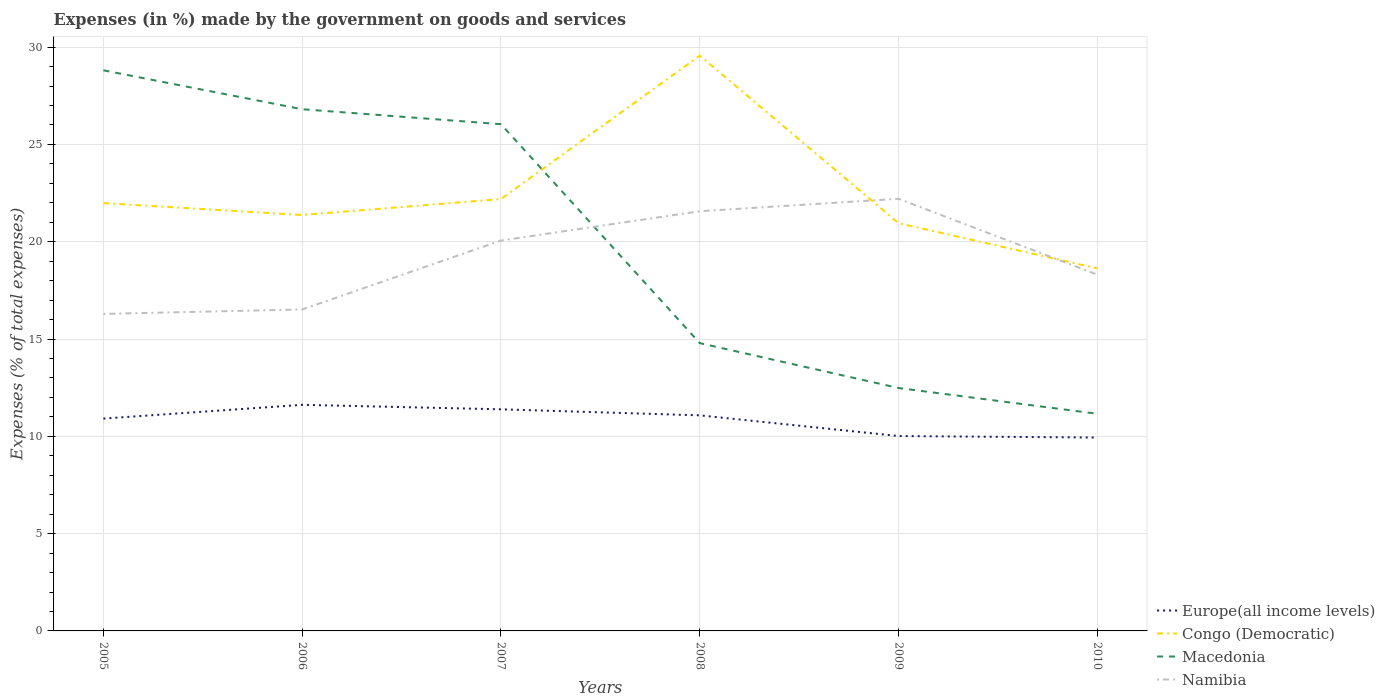Does the line corresponding to Namibia intersect with the line corresponding to Macedonia?
Keep it short and to the point. Yes. Is the number of lines equal to the number of legend labels?
Provide a short and direct response. Yes. Across all years, what is the maximum percentage of expenses made by the government on goods and services in Macedonia?
Keep it short and to the point. 11.16. In which year was the percentage of expenses made by the government on goods and services in Namibia maximum?
Offer a terse response. 2005. What is the total percentage of expenses made by the government on goods and services in Namibia in the graph?
Give a very brief answer. -5.92. What is the difference between the highest and the second highest percentage of expenses made by the government on goods and services in Congo (Democratic)?
Provide a short and direct response. 10.93. What is the difference between the highest and the lowest percentage of expenses made by the government on goods and services in Namibia?
Provide a succinct answer. 3. How many lines are there?
Offer a very short reply. 4. What is the difference between two consecutive major ticks on the Y-axis?
Give a very brief answer. 5. Are the values on the major ticks of Y-axis written in scientific E-notation?
Your response must be concise. No. Does the graph contain any zero values?
Provide a short and direct response. No. What is the title of the graph?
Offer a terse response. Expenses (in %) made by the government on goods and services. What is the label or title of the Y-axis?
Provide a succinct answer. Expenses (% of total expenses). What is the Expenses (% of total expenses) of Europe(all income levels) in 2005?
Give a very brief answer. 10.91. What is the Expenses (% of total expenses) of Congo (Democratic) in 2005?
Provide a succinct answer. 21.99. What is the Expenses (% of total expenses) of Macedonia in 2005?
Give a very brief answer. 28.81. What is the Expenses (% of total expenses) of Namibia in 2005?
Give a very brief answer. 16.29. What is the Expenses (% of total expenses) in Europe(all income levels) in 2006?
Ensure brevity in your answer.  11.62. What is the Expenses (% of total expenses) in Congo (Democratic) in 2006?
Provide a short and direct response. 21.37. What is the Expenses (% of total expenses) in Macedonia in 2006?
Your answer should be very brief. 26.81. What is the Expenses (% of total expenses) of Namibia in 2006?
Offer a terse response. 16.52. What is the Expenses (% of total expenses) of Europe(all income levels) in 2007?
Your response must be concise. 11.39. What is the Expenses (% of total expenses) of Congo (Democratic) in 2007?
Offer a terse response. 22.19. What is the Expenses (% of total expenses) of Macedonia in 2007?
Ensure brevity in your answer.  26.04. What is the Expenses (% of total expenses) in Namibia in 2007?
Ensure brevity in your answer.  20.06. What is the Expenses (% of total expenses) of Europe(all income levels) in 2008?
Provide a short and direct response. 11.08. What is the Expenses (% of total expenses) in Congo (Democratic) in 2008?
Provide a succinct answer. 29.56. What is the Expenses (% of total expenses) in Macedonia in 2008?
Provide a short and direct response. 14.79. What is the Expenses (% of total expenses) in Namibia in 2008?
Offer a terse response. 21.57. What is the Expenses (% of total expenses) in Europe(all income levels) in 2009?
Keep it short and to the point. 10.01. What is the Expenses (% of total expenses) in Congo (Democratic) in 2009?
Offer a very short reply. 20.95. What is the Expenses (% of total expenses) of Macedonia in 2009?
Ensure brevity in your answer.  12.48. What is the Expenses (% of total expenses) of Namibia in 2009?
Your answer should be compact. 22.21. What is the Expenses (% of total expenses) of Europe(all income levels) in 2010?
Provide a short and direct response. 9.94. What is the Expenses (% of total expenses) in Congo (Democratic) in 2010?
Your response must be concise. 18.63. What is the Expenses (% of total expenses) in Macedonia in 2010?
Keep it short and to the point. 11.16. What is the Expenses (% of total expenses) in Namibia in 2010?
Ensure brevity in your answer.  18.31. Across all years, what is the maximum Expenses (% of total expenses) in Europe(all income levels)?
Provide a short and direct response. 11.62. Across all years, what is the maximum Expenses (% of total expenses) of Congo (Democratic)?
Give a very brief answer. 29.56. Across all years, what is the maximum Expenses (% of total expenses) in Macedonia?
Offer a very short reply. 28.81. Across all years, what is the maximum Expenses (% of total expenses) in Namibia?
Give a very brief answer. 22.21. Across all years, what is the minimum Expenses (% of total expenses) in Europe(all income levels)?
Your answer should be very brief. 9.94. Across all years, what is the minimum Expenses (% of total expenses) of Congo (Democratic)?
Your answer should be very brief. 18.63. Across all years, what is the minimum Expenses (% of total expenses) of Macedonia?
Provide a short and direct response. 11.16. Across all years, what is the minimum Expenses (% of total expenses) in Namibia?
Provide a short and direct response. 16.29. What is the total Expenses (% of total expenses) of Europe(all income levels) in the graph?
Offer a very short reply. 64.95. What is the total Expenses (% of total expenses) of Congo (Democratic) in the graph?
Offer a terse response. 134.7. What is the total Expenses (% of total expenses) in Macedonia in the graph?
Keep it short and to the point. 120.09. What is the total Expenses (% of total expenses) in Namibia in the graph?
Offer a very short reply. 114.95. What is the difference between the Expenses (% of total expenses) of Europe(all income levels) in 2005 and that in 2006?
Provide a succinct answer. -0.71. What is the difference between the Expenses (% of total expenses) in Congo (Democratic) in 2005 and that in 2006?
Your answer should be compact. 0.61. What is the difference between the Expenses (% of total expenses) of Macedonia in 2005 and that in 2006?
Ensure brevity in your answer.  2. What is the difference between the Expenses (% of total expenses) in Namibia in 2005 and that in 2006?
Offer a terse response. -0.23. What is the difference between the Expenses (% of total expenses) in Europe(all income levels) in 2005 and that in 2007?
Your answer should be compact. -0.48. What is the difference between the Expenses (% of total expenses) in Congo (Democratic) in 2005 and that in 2007?
Your answer should be compact. -0.21. What is the difference between the Expenses (% of total expenses) in Macedonia in 2005 and that in 2007?
Keep it short and to the point. 2.77. What is the difference between the Expenses (% of total expenses) in Namibia in 2005 and that in 2007?
Your answer should be very brief. -3.77. What is the difference between the Expenses (% of total expenses) in Europe(all income levels) in 2005 and that in 2008?
Make the answer very short. -0.17. What is the difference between the Expenses (% of total expenses) of Congo (Democratic) in 2005 and that in 2008?
Your response must be concise. -7.58. What is the difference between the Expenses (% of total expenses) of Macedonia in 2005 and that in 2008?
Offer a very short reply. 14.02. What is the difference between the Expenses (% of total expenses) in Namibia in 2005 and that in 2008?
Give a very brief answer. -5.28. What is the difference between the Expenses (% of total expenses) of Europe(all income levels) in 2005 and that in 2009?
Offer a very short reply. 0.9. What is the difference between the Expenses (% of total expenses) of Congo (Democratic) in 2005 and that in 2009?
Give a very brief answer. 1.03. What is the difference between the Expenses (% of total expenses) in Macedonia in 2005 and that in 2009?
Offer a terse response. 16.33. What is the difference between the Expenses (% of total expenses) in Namibia in 2005 and that in 2009?
Your answer should be compact. -5.92. What is the difference between the Expenses (% of total expenses) in Europe(all income levels) in 2005 and that in 2010?
Offer a terse response. 0.97. What is the difference between the Expenses (% of total expenses) of Congo (Democratic) in 2005 and that in 2010?
Keep it short and to the point. 3.35. What is the difference between the Expenses (% of total expenses) in Macedonia in 2005 and that in 2010?
Provide a succinct answer. 17.65. What is the difference between the Expenses (% of total expenses) of Namibia in 2005 and that in 2010?
Provide a succinct answer. -2.02. What is the difference between the Expenses (% of total expenses) in Europe(all income levels) in 2006 and that in 2007?
Give a very brief answer. 0.23. What is the difference between the Expenses (% of total expenses) in Congo (Democratic) in 2006 and that in 2007?
Ensure brevity in your answer.  -0.82. What is the difference between the Expenses (% of total expenses) in Macedonia in 2006 and that in 2007?
Provide a succinct answer. 0.77. What is the difference between the Expenses (% of total expenses) in Namibia in 2006 and that in 2007?
Make the answer very short. -3.54. What is the difference between the Expenses (% of total expenses) in Europe(all income levels) in 2006 and that in 2008?
Offer a very short reply. 0.54. What is the difference between the Expenses (% of total expenses) in Congo (Democratic) in 2006 and that in 2008?
Your response must be concise. -8.19. What is the difference between the Expenses (% of total expenses) of Macedonia in 2006 and that in 2008?
Ensure brevity in your answer.  12.02. What is the difference between the Expenses (% of total expenses) of Namibia in 2006 and that in 2008?
Offer a very short reply. -5.05. What is the difference between the Expenses (% of total expenses) in Europe(all income levels) in 2006 and that in 2009?
Offer a very short reply. 1.6. What is the difference between the Expenses (% of total expenses) in Congo (Democratic) in 2006 and that in 2009?
Offer a terse response. 0.42. What is the difference between the Expenses (% of total expenses) of Macedonia in 2006 and that in 2009?
Keep it short and to the point. 14.33. What is the difference between the Expenses (% of total expenses) in Namibia in 2006 and that in 2009?
Offer a terse response. -5.69. What is the difference between the Expenses (% of total expenses) of Europe(all income levels) in 2006 and that in 2010?
Give a very brief answer. 1.68. What is the difference between the Expenses (% of total expenses) of Congo (Democratic) in 2006 and that in 2010?
Keep it short and to the point. 2.74. What is the difference between the Expenses (% of total expenses) of Macedonia in 2006 and that in 2010?
Your answer should be compact. 15.65. What is the difference between the Expenses (% of total expenses) of Namibia in 2006 and that in 2010?
Your response must be concise. -1.79. What is the difference between the Expenses (% of total expenses) of Europe(all income levels) in 2007 and that in 2008?
Your response must be concise. 0.31. What is the difference between the Expenses (% of total expenses) in Congo (Democratic) in 2007 and that in 2008?
Offer a very short reply. -7.37. What is the difference between the Expenses (% of total expenses) in Macedonia in 2007 and that in 2008?
Provide a short and direct response. 11.25. What is the difference between the Expenses (% of total expenses) in Namibia in 2007 and that in 2008?
Make the answer very short. -1.51. What is the difference between the Expenses (% of total expenses) in Europe(all income levels) in 2007 and that in 2009?
Offer a very short reply. 1.37. What is the difference between the Expenses (% of total expenses) in Congo (Democratic) in 2007 and that in 2009?
Make the answer very short. 1.24. What is the difference between the Expenses (% of total expenses) of Macedonia in 2007 and that in 2009?
Offer a terse response. 13.56. What is the difference between the Expenses (% of total expenses) in Namibia in 2007 and that in 2009?
Keep it short and to the point. -2.15. What is the difference between the Expenses (% of total expenses) of Europe(all income levels) in 2007 and that in 2010?
Ensure brevity in your answer.  1.45. What is the difference between the Expenses (% of total expenses) in Congo (Democratic) in 2007 and that in 2010?
Your answer should be very brief. 3.56. What is the difference between the Expenses (% of total expenses) of Macedonia in 2007 and that in 2010?
Your answer should be compact. 14.88. What is the difference between the Expenses (% of total expenses) of Namibia in 2007 and that in 2010?
Ensure brevity in your answer.  1.75. What is the difference between the Expenses (% of total expenses) in Europe(all income levels) in 2008 and that in 2009?
Make the answer very short. 1.06. What is the difference between the Expenses (% of total expenses) in Congo (Democratic) in 2008 and that in 2009?
Your response must be concise. 8.61. What is the difference between the Expenses (% of total expenses) in Macedonia in 2008 and that in 2009?
Your answer should be very brief. 2.31. What is the difference between the Expenses (% of total expenses) of Namibia in 2008 and that in 2009?
Make the answer very short. -0.64. What is the difference between the Expenses (% of total expenses) of Europe(all income levels) in 2008 and that in 2010?
Give a very brief answer. 1.14. What is the difference between the Expenses (% of total expenses) in Congo (Democratic) in 2008 and that in 2010?
Keep it short and to the point. 10.93. What is the difference between the Expenses (% of total expenses) in Macedonia in 2008 and that in 2010?
Your answer should be very brief. 3.63. What is the difference between the Expenses (% of total expenses) in Namibia in 2008 and that in 2010?
Provide a short and direct response. 3.26. What is the difference between the Expenses (% of total expenses) of Europe(all income levels) in 2009 and that in 2010?
Offer a very short reply. 0.08. What is the difference between the Expenses (% of total expenses) of Congo (Democratic) in 2009 and that in 2010?
Ensure brevity in your answer.  2.32. What is the difference between the Expenses (% of total expenses) in Macedonia in 2009 and that in 2010?
Offer a terse response. 1.32. What is the difference between the Expenses (% of total expenses) in Namibia in 2009 and that in 2010?
Offer a terse response. 3.9. What is the difference between the Expenses (% of total expenses) in Europe(all income levels) in 2005 and the Expenses (% of total expenses) in Congo (Democratic) in 2006?
Your answer should be very brief. -10.46. What is the difference between the Expenses (% of total expenses) in Europe(all income levels) in 2005 and the Expenses (% of total expenses) in Macedonia in 2006?
Your answer should be very brief. -15.9. What is the difference between the Expenses (% of total expenses) in Europe(all income levels) in 2005 and the Expenses (% of total expenses) in Namibia in 2006?
Make the answer very short. -5.61. What is the difference between the Expenses (% of total expenses) of Congo (Democratic) in 2005 and the Expenses (% of total expenses) of Macedonia in 2006?
Ensure brevity in your answer.  -4.82. What is the difference between the Expenses (% of total expenses) of Congo (Democratic) in 2005 and the Expenses (% of total expenses) of Namibia in 2006?
Provide a short and direct response. 5.47. What is the difference between the Expenses (% of total expenses) of Macedonia in 2005 and the Expenses (% of total expenses) of Namibia in 2006?
Provide a succinct answer. 12.29. What is the difference between the Expenses (% of total expenses) of Europe(all income levels) in 2005 and the Expenses (% of total expenses) of Congo (Democratic) in 2007?
Offer a very short reply. -11.28. What is the difference between the Expenses (% of total expenses) in Europe(all income levels) in 2005 and the Expenses (% of total expenses) in Macedonia in 2007?
Give a very brief answer. -15.13. What is the difference between the Expenses (% of total expenses) in Europe(all income levels) in 2005 and the Expenses (% of total expenses) in Namibia in 2007?
Ensure brevity in your answer.  -9.15. What is the difference between the Expenses (% of total expenses) of Congo (Democratic) in 2005 and the Expenses (% of total expenses) of Macedonia in 2007?
Your response must be concise. -4.05. What is the difference between the Expenses (% of total expenses) in Congo (Democratic) in 2005 and the Expenses (% of total expenses) in Namibia in 2007?
Your answer should be very brief. 1.92. What is the difference between the Expenses (% of total expenses) in Macedonia in 2005 and the Expenses (% of total expenses) in Namibia in 2007?
Provide a succinct answer. 8.75. What is the difference between the Expenses (% of total expenses) of Europe(all income levels) in 2005 and the Expenses (% of total expenses) of Congo (Democratic) in 2008?
Your response must be concise. -18.65. What is the difference between the Expenses (% of total expenses) in Europe(all income levels) in 2005 and the Expenses (% of total expenses) in Macedonia in 2008?
Keep it short and to the point. -3.88. What is the difference between the Expenses (% of total expenses) of Europe(all income levels) in 2005 and the Expenses (% of total expenses) of Namibia in 2008?
Provide a succinct answer. -10.66. What is the difference between the Expenses (% of total expenses) in Congo (Democratic) in 2005 and the Expenses (% of total expenses) in Macedonia in 2008?
Give a very brief answer. 7.2. What is the difference between the Expenses (% of total expenses) in Congo (Democratic) in 2005 and the Expenses (% of total expenses) in Namibia in 2008?
Your answer should be compact. 0.42. What is the difference between the Expenses (% of total expenses) in Macedonia in 2005 and the Expenses (% of total expenses) in Namibia in 2008?
Provide a succinct answer. 7.24. What is the difference between the Expenses (% of total expenses) of Europe(all income levels) in 2005 and the Expenses (% of total expenses) of Congo (Democratic) in 2009?
Ensure brevity in your answer.  -10.04. What is the difference between the Expenses (% of total expenses) of Europe(all income levels) in 2005 and the Expenses (% of total expenses) of Macedonia in 2009?
Your answer should be very brief. -1.57. What is the difference between the Expenses (% of total expenses) of Europe(all income levels) in 2005 and the Expenses (% of total expenses) of Namibia in 2009?
Your response must be concise. -11.3. What is the difference between the Expenses (% of total expenses) in Congo (Democratic) in 2005 and the Expenses (% of total expenses) in Macedonia in 2009?
Make the answer very short. 9.5. What is the difference between the Expenses (% of total expenses) in Congo (Democratic) in 2005 and the Expenses (% of total expenses) in Namibia in 2009?
Offer a terse response. -0.22. What is the difference between the Expenses (% of total expenses) of Macedonia in 2005 and the Expenses (% of total expenses) of Namibia in 2009?
Keep it short and to the point. 6.6. What is the difference between the Expenses (% of total expenses) in Europe(all income levels) in 2005 and the Expenses (% of total expenses) in Congo (Democratic) in 2010?
Your answer should be compact. -7.72. What is the difference between the Expenses (% of total expenses) of Europe(all income levels) in 2005 and the Expenses (% of total expenses) of Macedonia in 2010?
Give a very brief answer. -0.25. What is the difference between the Expenses (% of total expenses) of Europe(all income levels) in 2005 and the Expenses (% of total expenses) of Namibia in 2010?
Keep it short and to the point. -7.4. What is the difference between the Expenses (% of total expenses) of Congo (Democratic) in 2005 and the Expenses (% of total expenses) of Macedonia in 2010?
Offer a very short reply. 10.83. What is the difference between the Expenses (% of total expenses) of Congo (Democratic) in 2005 and the Expenses (% of total expenses) of Namibia in 2010?
Provide a short and direct response. 3.68. What is the difference between the Expenses (% of total expenses) in Macedonia in 2005 and the Expenses (% of total expenses) in Namibia in 2010?
Provide a succinct answer. 10.5. What is the difference between the Expenses (% of total expenses) in Europe(all income levels) in 2006 and the Expenses (% of total expenses) in Congo (Democratic) in 2007?
Your response must be concise. -10.57. What is the difference between the Expenses (% of total expenses) in Europe(all income levels) in 2006 and the Expenses (% of total expenses) in Macedonia in 2007?
Your answer should be compact. -14.42. What is the difference between the Expenses (% of total expenses) in Europe(all income levels) in 2006 and the Expenses (% of total expenses) in Namibia in 2007?
Provide a succinct answer. -8.44. What is the difference between the Expenses (% of total expenses) in Congo (Democratic) in 2006 and the Expenses (% of total expenses) in Macedonia in 2007?
Ensure brevity in your answer.  -4.67. What is the difference between the Expenses (% of total expenses) in Congo (Democratic) in 2006 and the Expenses (% of total expenses) in Namibia in 2007?
Keep it short and to the point. 1.31. What is the difference between the Expenses (% of total expenses) of Macedonia in 2006 and the Expenses (% of total expenses) of Namibia in 2007?
Offer a very short reply. 6.75. What is the difference between the Expenses (% of total expenses) of Europe(all income levels) in 2006 and the Expenses (% of total expenses) of Congo (Democratic) in 2008?
Your response must be concise. -17.94. What is the difference between the Expenses (% of total expenses) of Europe(all income levels) in 2006 and the Expenses (% of total expenses) of Macedonia in 2008?
Give a very brief answer. -3.17. What is the difference between the Expenses (% of total expenses) of Europe(all income levels) in 2006 and the Expenses (% of total expenses) of Namibia in 2008?
Give a very brief answer. -9.95. What is the difference between the Expenses (% of total expenses) of Congo (Democratic) in 2006 and the Expenses (% of total expenses) of Macedonia in 2008?
Your response must be concise. 6.58. What is the difference between the Expenses (% of total expenses) of Congo (Democratic) in 2006 and the Expenses (% of total expenses) of Namibia in 2008?
Keep it short and to the point. -0.2. What is the difference between the Expenses (% of total expenses) in Macedonia in 2006 and the Expenses (% of total expenses) in Namibia in 2008?
Offer a terse response. 5.24. What is the difference between the Expenses (% of total expenses) of Europe(all income levels) in 2006 and the Expenses (% of total expenses) of Congo (Democratic) in 2009?
Keep it short and to the point. -9.33. What is the difference between the Expenses (% of total expenses) in Europe(all income levels) in 2006 and the Expenses (% of total expenses) in Macedonia in 2009?
Provide a short and direct response. -0.86. What is the difference between the Expenses (% of total expenses) in Europe(all income levels) in 2006 and the Expenses (% of total expenses) in Namibia in 2009?
Your response must be concise. -10.59. What is the difference between the Expenses (% of total expenses) of Congo (Democratic) in 2006 and the Expenses (% of total expenses) of Macedonia in 2009?
Make the answer very short. 8.89. What is the difference between the Expenses (% of total expenses) of Congo (Democratic) in 2006 and the Expenses (% of total expenses) of Namibia in 2009?
Your answer should be very brief. -0.83. What is the difference between the Expenses (% of total expenses) in Macedonia in 2006 and the Expenses (% of total expenses) in Namibia in 2009?
Ensure brevity in your answer.  4.6. What is the difference between the Expenses (% of total expenses) of Europe(all income levels) in 2006 and the Expenses (% of total expenses) of Congo (Democratic) in 2010?
Provide a short and direct response. -7.01. What is the difference between the Expenses (% of total expenses) of Europe(all income levels) in 2006 and the Expenses (% of total expenses) of Macedonia in 2010?
Keep it short and to the point. 0.46. What is the difference between the Expenses (% of total expenses) in Europe(all income levels) in 2006 and the Expenses (% of total expenses) in Namibia in 2010?
Give a very brief answer. -6.69. What is the difference between the Expenses (% of total expenses) of Congo (Democratic) in 2006 and the Expenses (% of total expenses) of Macedonia in 2010?
Ensure brevity in your answer.  10.21. What is the difference between the Expenses (% of total expenses) in Congo (Democratic) in 2006 and the Expenses (% of total expenses) in Namibia in 2010?
Offer a very short reply. 3.06. What is the difference between the Expenses (% of total expenses) of Macedonia in 2006 and the Expenses (% of total expenses) of Namibia in 2010?
Make the answer very short. 8.5. What is the difference between the Expenses (% of total expenses) in Europe(all income levels) in 2007 and the Expenses (% of total expenses) in Congo (Democratic) in 2008?
Ensure brevity in your answer.  -18.17. What is the difference between the Expenses (% of total expenses) in Europe(all income levels) in 2007 and the Expenses (% of total expenses) in Macedonia in 2008?
Provide a short and direct response. -3.4. What is the difference between the Expenses (% of total expenses) of Europe(all income levels) in 2007 and the Expenses (% of total expenses) of Namibia in 2008?
Your response must be concise. -10.18. What is the difference between the Expenses (% of total expenses) in Congo (Democratic) in 2007 and the Expenses (% of total expenses) in Macedonia in 2008?
Your answer should be compact. 7.41. What is the difference between the Expenses (% of total expenses) of Congo (Democratic) in 2007 and the Expenses (% of total expenses) of Namibia in 2008?
Offer a very short reply. 0.63. What is the difference between the Expenses (% of total expenses) in Macedonia in 2007 and the Expenses (% of total expenses) in Namibia in 2008?
Provide a short and direct response. 4.47. What is the difference between the Expenses (% of total expenses) in Europe(all income levels) in 2007 and the Expenses (% of total expenses) in Congo (Democratic) in 2009?
Your answer should be very brief. -9.56. What is the difference between the Expenses (% of total expenses) in Europe(all income levels) in 2007 and the Expenses (% of total expenses) in Macedonia in 2009?
Your answer should be compact. -1.09. What is the difference between the Expenses (% of total expenses) of Europe(all income levels) in 2007 and the Expenses (% of total expenses) of Namibia in 2009?
Provide a short and direct response. -10.82. What is the difference between the Expenses (% of total expenses) in Congo (Democratic) in 2007 and the Expenses (% of total expenses) in Macedonia in 2009?
Keep it short and to the point. 9.71. What is the difference between the Expenses (% of total expenses) of Congo (Democratic) in 2007 and the Expenses (% of total expenses) of Namibia in 2009?
Give a very brief answer. -0.01. What is the difference between the Expenses (% of total expenses) in Macedonia in 2007 and the Expenses (% of total expenses) in Namibia in 2009?
Keep it short and to the point. 3.83. What is the difference between the Expenses (% of total expenses) in Europe(all income levels) in 2007 and the Expenses (% of total expenses) in Congo (Democratic) in 2010?
Provide a succinct answer. -7.24. What is the difference between the Expenses (% of total expenses) in Europe(all income levels) in 2007 and the Expenses (% of total expenses) in Macedonia in 2010?
Offer a very short reply. 0.23. What is the difference between the Expenses (% of total expenses) of Europe(all income levels) in 2007 and the Expenses (% of total expenses) of Namibia in 2010?
Make the answer very short. -6.92. What is the difference between the Expenses (% of total expenses) in Congo (Democratic) in 2007 and the Expenses (% of total expenses) in Macedonia in 2010?
Ensure brevity in your answer.  11.03. What is the difference between the Expenses (% of total expenses) of Congo (Democratic) in 2007 and the Expenses (% of total expenses) of Namibia in 2010?
Offer a very short reply. 3.89. What is the difference between the Expenses (% of total expenses) in Macedonia in 2007 and the Expenses (% of total expenses) in Namibia in 2010?
Your answer should be compact. 7.73. What is the difference between the Expenses (% of total expenses) in Europe(all income levels) in 2008 and the Expenses (% of total expenses) in Congo (Democratic) in 2009?
Your answer should be compact. -9.87. What is the difference between the Expenses (% of total expenses) in Europe(all income levels) in 2008 and the Expenses (% of total expenses) in Macedonia in 2009?
Provide a short and direct response. -1.4. What is the difference between the Expenses (% of total expenses) in Europe(all income levels) in 2008 and the Expenses (% of total expenses) in Namibia in 2009?
Give a very brief answer. -11.13. What is the difference between the Expenses (% of total expenses) of Congo (Democratic) in 2008 and the Expenses (% of total expenses) of Macedonia in 2009?
Your response must be concise. 17.08. What is the difference between the Expenses (% of total expenses) in Congo (Democratic) in 2008 and the Expenses (% of total expenses) in Namibia in 2009?
Your answer should be very brief. 7.35. What is the difference between the Expenses (% of total expenses) in Macedonia in 2008 and the Expenses (% of total expenses) in Namibia in 2009?
Give a very brief answer. -7.42. What is the difference between the Expenses (% of total expenses) in Europe(all income levels) in 2008 and the Expenses (% of total expenses) in Congo (Democratic) in 2010?
Provide a short and direct response. -7.55. What is the difference between the Expenses (% of total expenses) of Europe(all income levels) in 2008 and the Expenses (% of total expenses) of Macedonia in 2010?
Ensure brevity in your answer.  -0.08. What is the difference between the Expenses (% of total expenses) in Europe(all income levels) in 2008 and the Expenses (% of total expenses) in Namibia in 2010?
Ensure brevity in your answer.  -7.23. What is the difference between the Expenses (% of total expenses) in Congo (Democratic) in 2008 and the Expenses (% of total expenses) in Macedonia in 2010?
Make the answer very short. 18.4. What is the difference between the Expenses (% of total expenses) in Congo (Democratic) in 2008 and the Expenses (% of total expenses) in Namibia in 2010?
Keep it short and to the point. 11.25. What is the difference between the Expenses (% of total expenses) of Macedonia in 2008 and the Expenses (% of total expenses) of Namibia in 2010?
Your answer should be very brief. -3.52. What is the difference between the Expenses (% of total expenses) in Europe(all income levels) in 2009 and the Expenses (% of total expenses) in Congo (Democratic) in 2010?
Your response must be concise. -8.62. What is the difference between the Expenses (% of total expenses) in Europe(all income levels) in 2009 and the Expenses (% of total expenses) in Macedonia in 2010?
Your answer should be compact. -1.14. What is the difference between the Expenses (% of total expenses) in Europe(all income levels) in 2009 and the Expenses (% of total expenses) in Namibia in 2010?
Provide a succinct answer. -8.29. What is the difference between the Expenses (% of total expenses) of Congo (Democratic) in 2009 and the Expenses (% of total expenses) of Macedonia in 2010?
Offer a terse response. 9.79. What is the difference between the Expenses (% of total expenses) of Congo (Democratic) in 2009 and the Expenses (% of total expenses) of Namibia in 2010?
Offer a terse response. 2.64. What is the difference between the Expenses (% of total expenses) in Macedonia in 2009 and the Expenses (% of total expenses) in Namibia in 2010?
Your answer should be very brief. -5.83. What is the average Expenses (% of total expenses) of Europe(all income levels) per year?
Provide a short and direct response. 10.82. What is the average Expenses (% of total expenses) in Congo (Democratic) per year?
Provide a succinct answer. 22.45. What is the average Expenses (% of total expenses) in Macedonia per year?
Offer a very short reply. 20.01. What is the average Expenses (% of total expenses) of Namibia per year?
Make the answer very short. 19.16. In the year 2005, what is the difference between the Expenses (% of total expenses) in Europe(all income levels) and Expenses (% of total expenses) in Congo (Democratic)?
Offer a very short reply. -11.07. In the year 2005, what is the difference between the Expenses (% of total expenses) of Europe(all income levels) and Expenses (% of total expenses) of Macedonia?
Give a very brief answer. -17.9. In the year 2005, what is the difference between the Expenses (% of total expenses) of Europe(all income levels) and Expenses (% of total expenses) of Namibia?
Offer a terse response. -5.38. In the year 2005, what is the difference between the Expenses (% of total expenses) of Congo (Democratic) and Expenses (% of total expenses) of Macedonia?
Give a very brief answer. -6.82. In the year 2005, what is the difference between the Expenses (% of total expenses) of Congo (Democratic) and Expenses (% of total expenses) of Namibia?
Ensure brevity in your answer.  5.69. In the year 2005, what is the difference between the Expenses (% of total expenses) of Macedonia and Expenses (% of total expenses) of Namibia?
Your response must be concise. 12.52. In the year 2006, what is the difference between the Expenses (% of total expenses) in Europe(all income levels) and Expenses (% of total expenses) in Congo (Democratic)?
Offer a terse response. -9.75. In the year 2006, what is the difference between the Expenses (% of total expenses) of Europe(all income levels) and Expenses (% of total expenses) of Macedonia?
Keep it short and to the point. -15.19. In the year 2006, what is the difference between the Expenses (% of total expenses) in Europe(all income levels) and Expenses (% of total expenses) in Namibia?
Make the answer very short. -4.9. In the year 2006, what is the difference between the Expenses (% of total expenses) in Congo (Democratic) and Expenses (% of total expenses) in Macedonia?
Give a very brief answer. -5.44. In the year 2006, what is the difference between the Expenses (% of total expenses) in Congo (Democratic) and Expenses (% of total expenses) in Namibia?
Your answer should be compact. 4.85. In the year 2006, what is the difference between the Expenses (% of total expenses) of Macedonia and Expenses (% of total expenses) of Namibia?
Provide a succinct answer. 10.29. In the year 2007, what is the difference between the Expenses (% of total expenses) in Europe(all income levels) and Expenses (% of total expenses) in Congo (Democratic)?
Your answer should be very brief. -10.81. In the year 2007, what is the difference between the Expenses (% of total expenses) in Europe(all income levels) and Expenses (% of total expenses) in Macedonia?
Give a very brief answer. -14.65. In the year 2007, what is the difference between the Expenses (% of total expenses) in Europe(all income levels) and Expenses (% of total expenses) in Namibia?
Offer a terse response. -8.67. In the year 2007, what is the difference between the Expenses (% of total expenses) of Congo (Democratic) and Expenses (% of total expenses) of Macedonia?
Provide a short and direct response. -3.85. In the year 2007, what is the difference between the Expenses (% of total expenses) of Congo (Democratic) and Expenses (% of total expenses) of Namibia?
Offer a very short reply. 2.13. In the year 2007, what is the difference between the Expenses (% of total expenses) of Macedonia and Expenses (% of total expenses) of Namibia?
Your answer should be compact. 5.98. In the year 2008, what is the difference between the Expenses (% of total expenses) in Europe(all income levels) and Expenses (% of total expenses) in Congo (Democratic)?
Your answer should be compact. -18.48. In the year 2008, what is the difference between the Expenses (% of total expenses) of Europe(all income levels) and Expenses (% of total expenses) of Macedonia?
Your response must be concise. -3.71. In the year 2008, what is the difference between the Expenses (% of total expenses) of Europe(all income levels) and Expenses (% of total expenses) of Namibia?
Offer a very short reply. -10.49. In the year 2008, what is the difference between the Expenses (% of total expenses) of Congo (Democratic) and Expenses (% of total expenses) of Macedonia?
Keep it short and to the point. 14.77. In the year 2008, what is the difference between the Expenses (% of total expenses) of Congo (Democratic) and Expenses (% of total expenses) of Namibia?
Your answer should be very brief. 7.99. In the year 2008, what is the difference between the Expenses (% of total expenses) in Macedonia and Expenses (% of total expenses) in Namibia?
Keep it short and to the point. -6.78. In the year 2009, what is the difference between the Expenses (% of total expenses) of Europe(all income levels) and Expenses (% of total expenses) of Congo (Democratic)?
Provide a succinct answer. -10.94. In the year 2009, what is the difference between the Expenses (% of total expenses) of Europe(all income levels) and Expenses (% of total expenses) of Macedonia?
Make the answer very short. -2.47. In the year 2009, what is the difference between the Expenses (% of total expenses) of Europe(all income levels) and Expenses (% of total expenses) of Namibia?
Ensure brevity in your answer.  -12.19. In the year 2009, what is the difference between the Expenses (% of total expenses) of Congo (Democratic) and Expenses (% of total expenses) of Macedonia?
Provide a succinct answer. 8.47. In the year 2009, what is the difference between the Expenses (% of total expenses) in Congo (Democratic) and Expenses (% of total expenses) in Namibia?
Offer a terse response. -1.26. In the year 2009, what is the difference between the Expenses (% of total expenses) of Macedonia and Expenses (% of total expenses) of Namibia?
Provide a succinct answer. -9.72. In the year 2010, what is the difference between the Expenses (% of total expenses) in Europe(all income levels) and Expenses (% of total expenses) in Congo (Democratic)?
Your response must be concise. -8.69. In the year 2010, what is the difference between the Expenses (% of total expenses) of Europe(all income levels) and Expenses (% of total expenses) of Macedonia?
Provide a succinct answer. -1.22. In the year 2010, what is the difference between the Expenses (% of total expenses) of Europe(all income levels) and Expenses (% of total expenses) of Namibia?
Provide a succinct answer. -8.37. In the year 2010, what is the difference between the Expenses (% of total expenses) in Congo (Democratic) and Expenses (% of total expenses) in Macedonia?
Offer a terse response. 7.47. In the year 2010, what is the difference between the Expenses (% of total expenses) in Congo (Democratic) and Expenses (% of total expenses) in Namibia?
Your response must be concise. 0.32. In the year 2010, what is the difference between the Expenses (% of total expenses) of Macedonia and Expenses (% of total expenses) of Namibia?
Provide a succinct answer. -7.15. What is the ratio of the Expenses (% of total expenses) in Europe(all income levels) in 2005 to that in 2006?
Provide a short and direct response. 0.94. What is the ratio of the Expenses (% of total expenses) in Congo (Democratic) in 2005 to that in 2006?
Keep it short and to the point. 1.03. What is the ratio of the Expenses (% of total expenses) in Macedonia in 2005 to that in 2006?
Offer a very short reply. 1.07. What is the ratio of the Expenses (% of total expenses) in Namibia in 2005 to that in 2006?
Your answer should be compact. 0.99. What is the ratio of the Expenses (% of total expenses) of Europe(all income levels) in 2005 to that in 2007?
Your answer should be very brief. 0.96. What is the ratio of the Expenses (% of total expenses) of Congo (Democratic) in 2005 to that in 2007?
Keep it short and to the point. 0.99. What is the ratio of the Expenses (% of total expenses) of Macedonia in 2005 to that in 2007?
Your answer should be very brief. 1.11. What is the ratio of the Expenses (% of total expenses) of Namibia in 2005 to that in 2007?
Provide a succinct answer. 0.81. What is the ratio of the Expenses (% of total expenses) of Congo (Democratic) in 2005 to that in 2008?
Keep it short and to the point. 0.74. What is the ratio of the Expenses (% of total expenses) in Macedonia in 2005 to that in 2008?
Give a very brief answer. 1.95. What is the ratio of the Expenses (% of total expenses) in Namibia in 2005 to that in 2008?
Give a very brief answer. 0.76. What is the ratio of the Expenses (% of total expenses) in Europe(all income levels) in 2005 to that in 2009?
Ensure brevity in your answer.  1.09. What is the ratio of the Expenses (% of total expenses) in Congo (Democratic) in 2005 to that in 2009?
Make the answer very short. 1.05. What is the ratio of the Expenses (% of total expenses) in Macedonia in 2005 to that in 2009?
Give a very brief answer. 2.31. What is the ratio of the Expenses (% of total expenses) of Namibia in 2005 to that in 2009?
Your answer should be compact. 0.73. What is the ratio of the Expenses (% of total expenses) in Europe(all income levels) in 2005 to that in 2010?
Make the answer very short. 1.1. What is the ratio of the Expenses (% of total expenses) in Congo (Democratic) in 2005 to that in 2010?
Offer a terse response. 1.18. What is the ratio of the Expenses (% of total expenses) of Macedonia in 2005 to that in 2010?
Provide a succinct answer. 2.58. What is the ratio of the Expenses (% of total expenses) of Namibia in 2005 to that in 2010?
Your answer should be very brief. 0.89. What is the ratio of the Expenses (% of total expenses) of Europe(all income levels) in 2006 to that in 2007?
Ensure brevity in your answer.  1.02. What is the ratio of the Expenses (% of total expenses) of Macedonia in 2006 to that in 2007?
Offer a very short reply. 1.03. What is the ratio of the Expenses (% of total expenses) in Namibia in 2006 to that in 2007?
Make the answer very short. 0.82. What is the ratio of the Expenses (% of total expenses) of Europe(all income levels) in 2006 to that in 2008?
Your answer should be very brief. 1.05. What is the ratio of the Expenses (% of total expenses) in Congo (Democratic) in 2006 to that in 2008?
Offer a very short reply. 0.72. What is the ratio of the Expenses (% of total expenses) of Macedonia in 2006 to that in 2008?
Your response must be concise. 1.81. What is the ratio of the Expenses (% of total expenses) of Namibia in 2006 to that in 2008?
Make the answer very short. 0.77. What is the ratio of the Expenses (% of total expenses) in Europe(all income levels) in 2006 to that in 2009?
Keep it short and to the point. 1.16. What is the ratio of the Expenses (% of total expenses) of Congo (Democratic) in 2006 to that in 2009?
Provide a short and direct response. 1.02. What is the ratio of the Expenses (% of total expenses) of Macedonia in 2006 to that in 2009?
Offer a very short reply. 2.15. What is the ratio of the Expenses (% of total expenses) of Namibia in 2006 to that in 2009?
Make the answer very short. 0.74. What is the ratio of the Expenses (% of total expenses) of Europe(all income levels) in 2006 to that in 2010?
Make the answer very short. 1.17. What is the ratio of the Expenses (% of total expenses) of Congo (Democratic) in 2006 to that in 2010?
Your answer should be very brief. 1.15. What is the ratio of the Expenses (% of total expenses) of Macedonia in 2006 to that in 2010?
Provide a succinct answer. 2.4. What is the ratio of the Expenses (% of total expenses) in Namibia in 2006 to that in 2010?
Offer a terse response. 0.9. What is the ratio of the Expenses (% of total expenses) of Europe(all income levels) in 2007 to that in 2008?
Offer a terse response. 1.03. What is the ratio of the Expenses (% of total expenses) in Congo (Democratic) in 2007 to that in 2008?
Offer a very short reply. 0.75. What is the ratio of the Expenses (% of total expenses) of Macedonia in 2007 to that in 2008?
Offer a very short reply. 1.76. What is the ratio of the Expenses (% of total expenses) of Namibia in 2007 to that in 2008?
Your answer should be compact. 0.93. What is the ratio of the Expenses (% of total expenses) of Europe(all income levels) in 2007 to that in 2009?
Keep it short and to the point. 1.14. What is the ratio of the Expenses (% of total expenses) in Congo (Democratic) in 2007 to that in 2009?
Offer a very short reply. 1.06. What is the ratio of the Expenses (% of total expenses) of Macedonia in 2007 to that in 2009?
Offer a terse response. 2.09. What is the ratio of the Expenses (% of total expenses) of Namibia in 2007 to that in 2009?
Give a very brief answer. 0.9. What is the ratio of the Expenses (% of total expenses) in Europe(all income levels) in 2007 to that in 2010?
Your answer should be very brief. 1.15. What is the ratio of the Expenses (% of total expenses) in Congo (Democratic) in 2007 to that in 2010?
Your answer should be compact. 1.19. What is the ratio of the Expenses (% of total expenses) in Macedonia in 2007 to that in 2010?
Keep it short and to the point. 2.33. What is the ratio of the Expenses (% of total expenses) of Namibia in 2007 to that in 2010?
Give a very brief answer. 1.1. What is the ratio of the Expenses (% of total expenses) of Europe(all income levels) in 2008 to that in 2009?
Ensure brevity in your answer.  1.11. What is the ratio of the Expenses (% of total expenses) in Congo (Democratic) in 2008 to that in 2009?
Your answer should be very brief. 1.41. What is the ratio of the Expenses (% of total expenses) of Macedonia in 2008 to that in 2009?
Provide a succinct answer. 1.18. What is the ratio of the Expenses (% of total expenses) in Namibia in 2008 to that in 2009?
Offer a terse response. 0.97. What is the ratio of the Expenses (% of total expenses) in Europe(all income levels) in 2008 to that in 2010?
Keep it short and to the point. 1.11. What is the ratio of the Expenses (% of total expenses) in Congo (Democratic) in 2008 to that in 2010?
Ensure brevity in your answer.  1.59. What is the ratio of the Expenses (% of total expenses) of Macedonia in 2008 to that in 2010?
Your response must be concise. 1.33. What is the ratio of the Expenses (% of total expenses) in Namibia in 2008 to that in 2010?
Your answer should be compact. 1.18. What is the ratio of the Expenses (% of total expenses) of Europe(all income levels) in 2009 to that in 2010?
Your answer should be compact. 1.01. What is the ratio of the Expenses (% of total expenses) of Congo (Democratic) in 2009 to that in 2010?
Offer a very short reply. 1.12. What is the ratio of the Expenses (% of total expenses) in Macedonia in 2009 to that in 2010?
Ensure brevity in your answer.  1.12. What is the ratio of the Expenses (% of total expenses) of Namibia in 2009 to that in 2010?
Provide a succinct answer. 1.21. What is the difference between the highest and the second highest Expenses (% of total expenses) of Europe(all income levels)?
Your response must be concise. 0.23. What is the difference between the highest and the second highest Expenses (% of total expenses) in Congo (Democratic)?
Make the answer very short. 7.37. What is the difference between the highest and the second highest Expenses (% of total expenses) of Macedonia?
Your answer should be compact. 2. What is the difference between the highest and the second highest Expenses (% of total expenses) of Namibia?
Provide a succinct answer. 0.64. What is the difference between the highest and the lowest Expenses (% of total expenses) in Europe(all income levels)?
Your answer should be compact. 1.68. What is the difference between the highest and the lowest Expenses (% of total expenses) in Congo (Democratic)?
Offer a very short reply. 10.93. What is the difference between the highest and the lowest Expenses (% of total expenses) in Macedonia?
Provide a short and direct response. 17.65. What is the difference between the highest and the lowest Expenses (% of total expenses) in Namibia?
Ensure brevity in your answer.  5.92. 